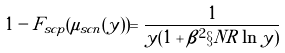Convert formula to latex. <formula><loc_0><loc_0><loc_500><loc_500>1 - F _ { s c p } ( \mu _ { s c n } ( y ) ) = \frac { 1 } { y ( 1 + \beta ^ { 2 } \S N R \ln y ) }</formula> 